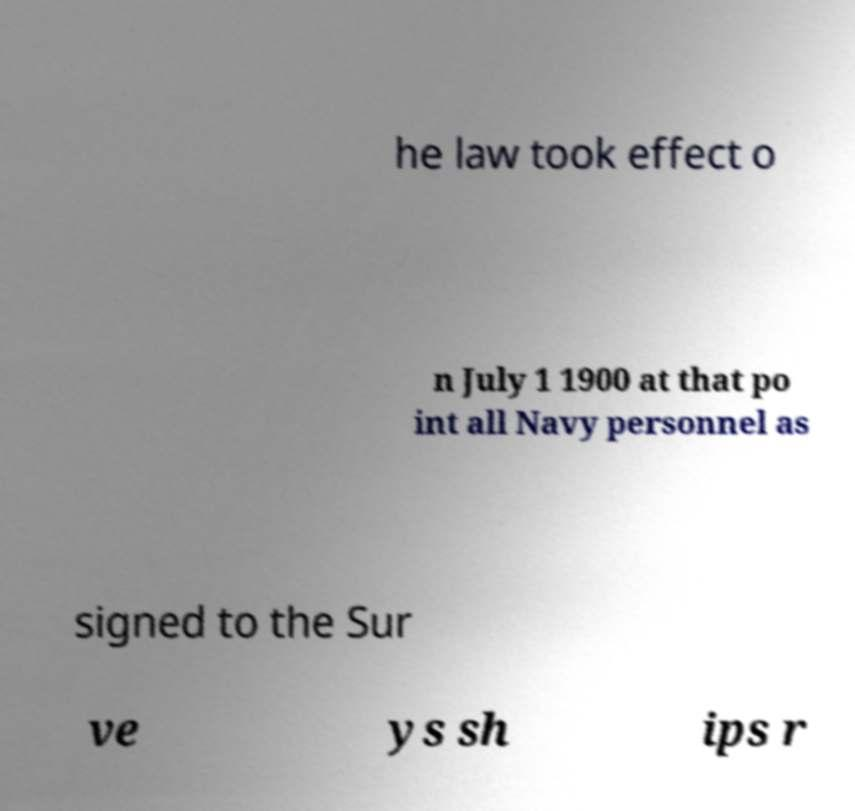What messages or text are displayed in this image? I need them in a readable, typed format. he law took effect o n July 1 1900 at that po int all Navy personnel as signed to the Sur ve ys sh ips r 